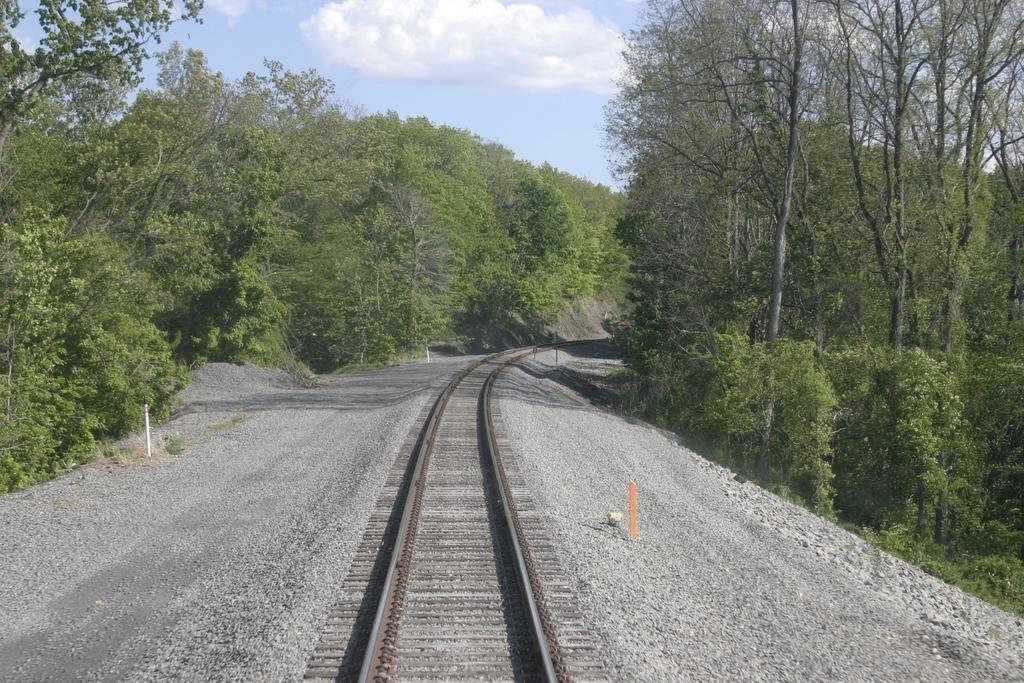What is the main subject of the image? The main subject of the image is a railway track. What can be seen in the background of the image? There is a group of trees and the sky visible in the background of the image. Can you see a laborer working on the railway track in the image? There is no laborer present in the image. Is there a giraffe visible among the trees in the background of the image? There is no giraffe present in the image; only trees and the sky are visible in the background. 